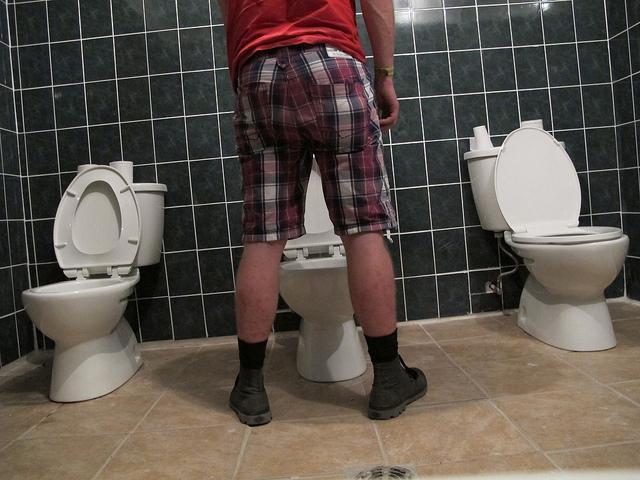How many drains are in this rest room's floor?
Give a very brief answer. 1. How many toilets is there?
Give a very brief answer. 3. How many toilets can be seen?
Give a very brief answer. 3. How many light colored trucks are there?
Give a very brief answer. 0. 